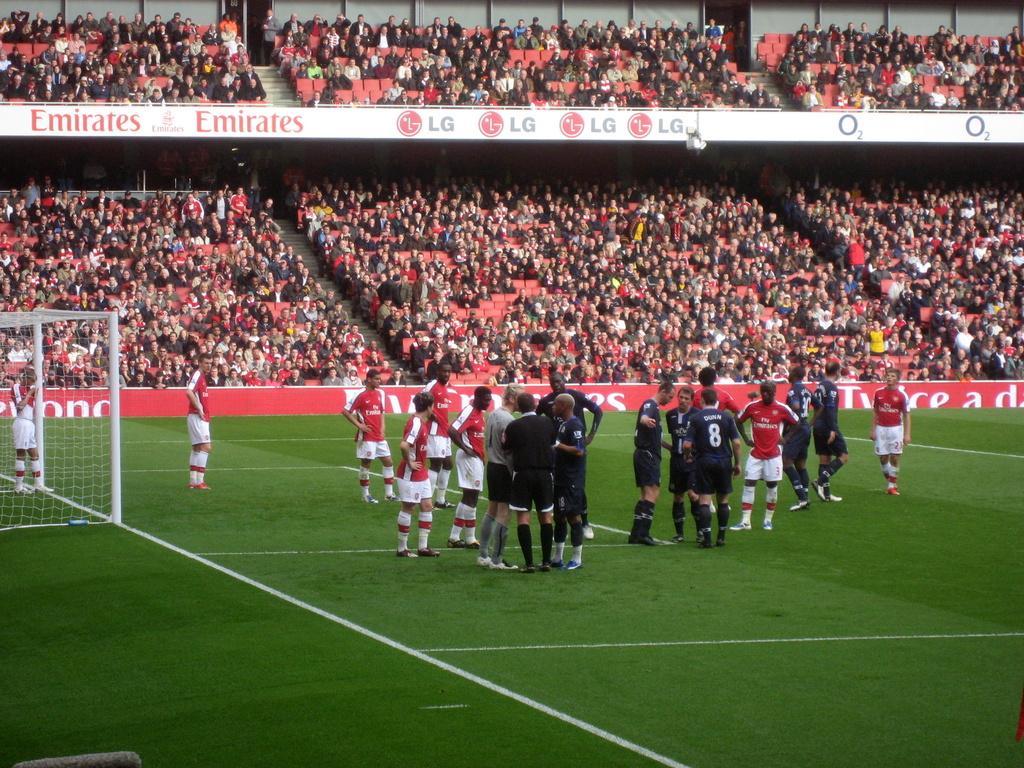Describe this image in one or two sentences. In this image there is a football ground, there are player standing on the ground, towards the left there is a net, there are audience sitting, there are staircase, there are red color chairs, there is a board on which text is written. 